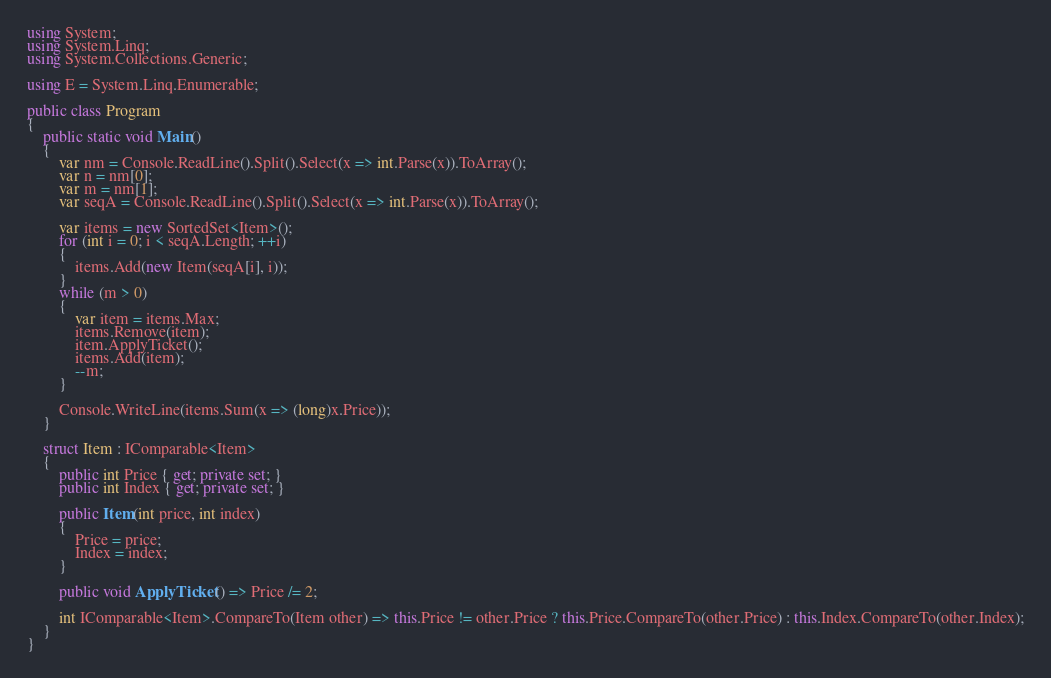Convert code to text. <code><loc_0><loc_0><loc_500><loc_500><_C#_>using System;
using System.Linq;
using System.Collections.Generic;

using E = System.Linq.Enumerable;

public class Program
{
    public static void Main()
    {
        var nm = Console.ReadLine().Split().Select(x => int.Parse(x)).ToArray();
        var n = nm[0];
        var m = nm[1];
        var seqA = Console.ReadLine().Split().Select(x => int.Parse(x)).ToArray();

        var items = new SortedSet<Item>();
        for (int i = 0; i < seqA.Length; ++i)
        {
            items.Add(new Item(seqA[i], i));
        }
        while (m > 0)
        {
            var item = items.Max;
            items.Remove(item);
            item.ApplyTicket();
            items.Add(item);
            --m;
        }
        
        Console.WriteLine(items.Sum(x => (long)x.Price));
    }

    struct Item : IComparable<Item>
    {
        public int Price { get; private set; }
        public int Index { get; private set; }

        public Item(int price, int index)
        {
            Price = price;
            Index = index;
        }

        public void ApplyTicket() => Price /= 2;

        int IComparable<Item>.CompareTo(Item other) => this.Price != other.Price ? this.Price.CompareTo(other.Price) : this.Index.CompareTo(other.Index);
    }
}
</code> 